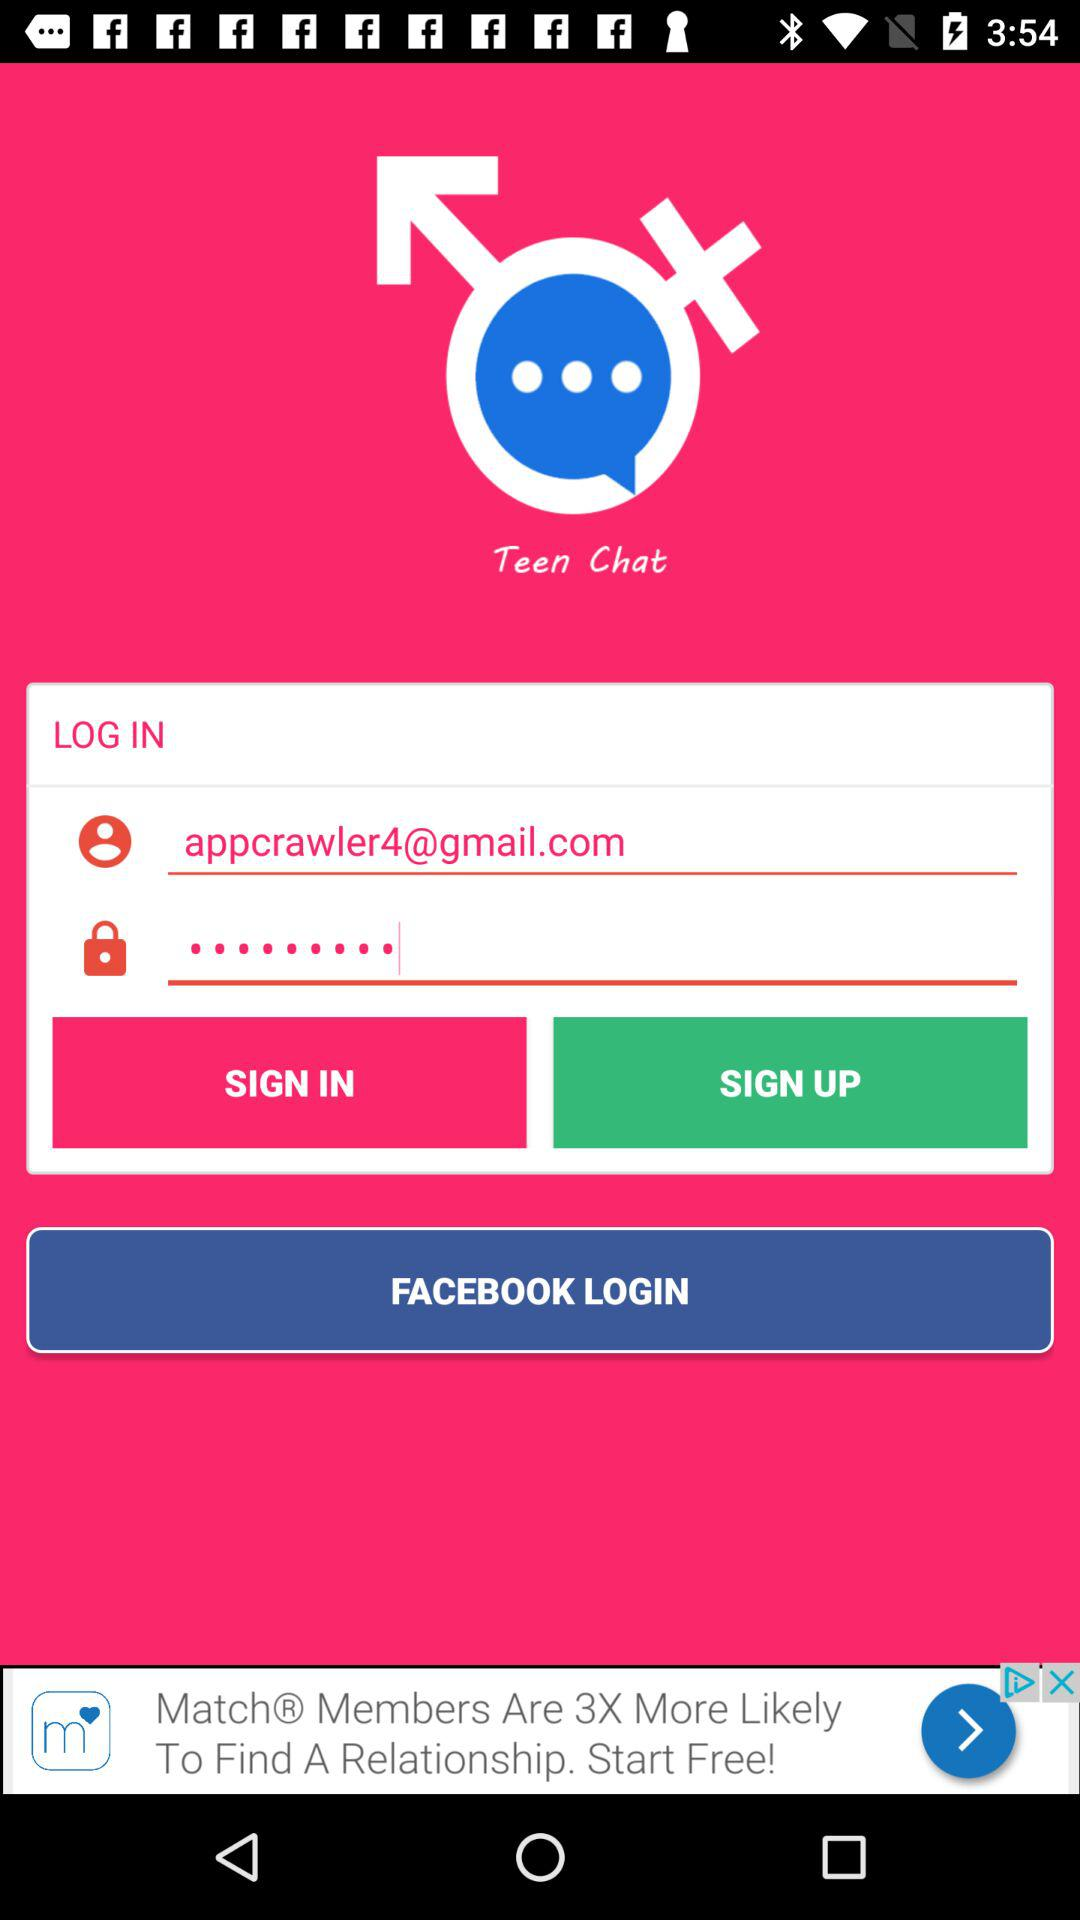What are the different options available to log in? The option available to log in is "FACEBOOK". 